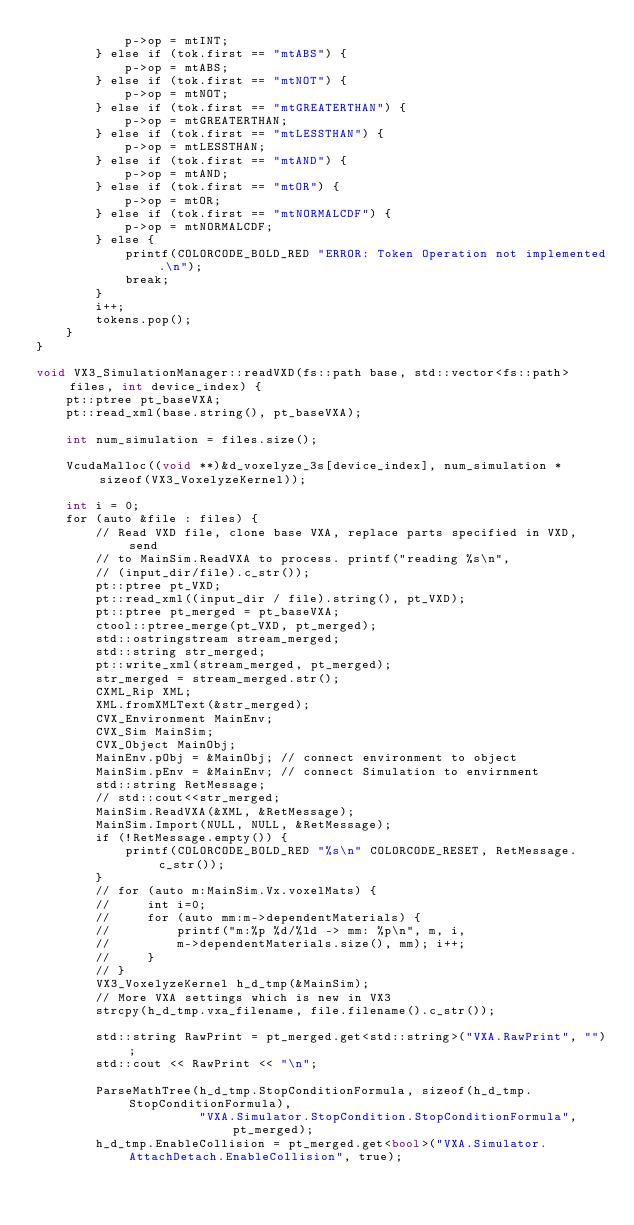Convert code to text. <code><loc_0><loc_0><loc_500><loc_500><_Cuda_>            p->op = mtINT;
        } else if (tok.first == "mtABS") {
            p->op = mtABS;
        } else if (tok.first == "mtNOT") {
            p->op = mtNOT;
        } else if (tok.first == "mtGREATERTHAN") {
            p->op = mtGREATERTHAN;
        } else if (tok.first == "mtLESSTHAN") {
            p->op = mtLESSTHAN;
        } else if (tok.first == "mtAND") {
            p->op = mtAND;
        } else if (tok.first == "mtOR") {
            p->op = mtOR;
        } else if (tok.first == "mtNORMALCDF") {
            p->op = mtNORMALCDF;
        } else {
            printf(COLORCODE_BOLD_RED "ERROR: Token Operation not implemented.\n");
            break;
        }
        i++;
        tokens.pop();
    }
}

void VX3_SimulationManager::readVXD(fs::path base, std::vector<fs::path> files, int device_index) {
    pt::ptree pt_baseVXA;
    pt::read_xml(base.string(), pt_baseVXA);

    int num_simulation = files.size();

    VcudaMalloc((void **)&d_voxelyze_3s[device_index], num_simulation * sizeof(VX3_VoxelyzeKernel));

    int i = 0;
    for (auto &file : files) {
        // Read VXD file, clone base VXA, replace parts specified in VXD, send
        // to MainSim.ReadVXA to process. printf("reading %s\n",
        // (input_dir/file).c_str());
        pt::ptree pt_VXD;
        pt::read_xml((input_dir / file).string(), pt_VXD);
        pt::ptree pt_merged = pt_baseVXA;
        ctool::ptree_merge(pt_VXD, pt_merged);
        std::ostringstream stream_merged;
        std::string str_merged;
        pt::write_xml(stream_merged, pt_merged);
        str_merged = stream_merged.str();
        CXML_Rip XML;
        XML.fromXMLText(&str_merged);
        CVX_Environment MainEnv;
        CVX_Sim MainSim;
        CVX_Object MainObj;
        MainEnv.pObj = &MainObj; // connect environment to object
        MainSim.pEnv = &MainEnv; // connect Simulation to envirnment
        std::string RetMessage;
        // std::cout<<str_merged;
        MainSim.ReadVXA(&XML, &RetMessage);
        MainSim.Import(NULL, NULL, &RetMessage);
        if (!RetMessage.empty()) {
            printf(COLORCODE_BOLD_RED "%s\n" COLORCODE_RESET, RetMessage.c_str());
        }
        // for (auto m:MainSim.Vx.voxelMats) {
        //     int i=0;
        //     for (auto mm:m->dependentMaterials) {
        //         printf("m:%p %d/%ld -> mm: %p\n", m, i,
        //         m->dependentMaterials.size(), mm); i++;
        //     }
        // }
        VX3_VoxelyzeKernel h_d_tmp(&MainSim);
        // More VXA settings which is new in VX3
        strcpy(h_d_tmp.vxa_filename, file.filename().c_str());

        std::string RawPrint = pt_merged.get<std::string>("VXA.RawPrint", "");
        std::cout << RawPrint << "\n";

        ParseMathTree(h_d_tmp.StopConditionFormula, sizeof(h_d_tmp.StopConditionFormula),
                      "VXA.Simulator.StopCondition.StopConditionFormula", pt_merged);
        h_d_tmp.EnableCollision = pt_merged.get<bool>("VXA.Simulator.AttachDetach.EnableCollision", true);</code> 